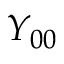Convert formula to latex. <formula><loc_0><loc_0><loc_500><loc_500>Y _ { 0 0 }</formula> 